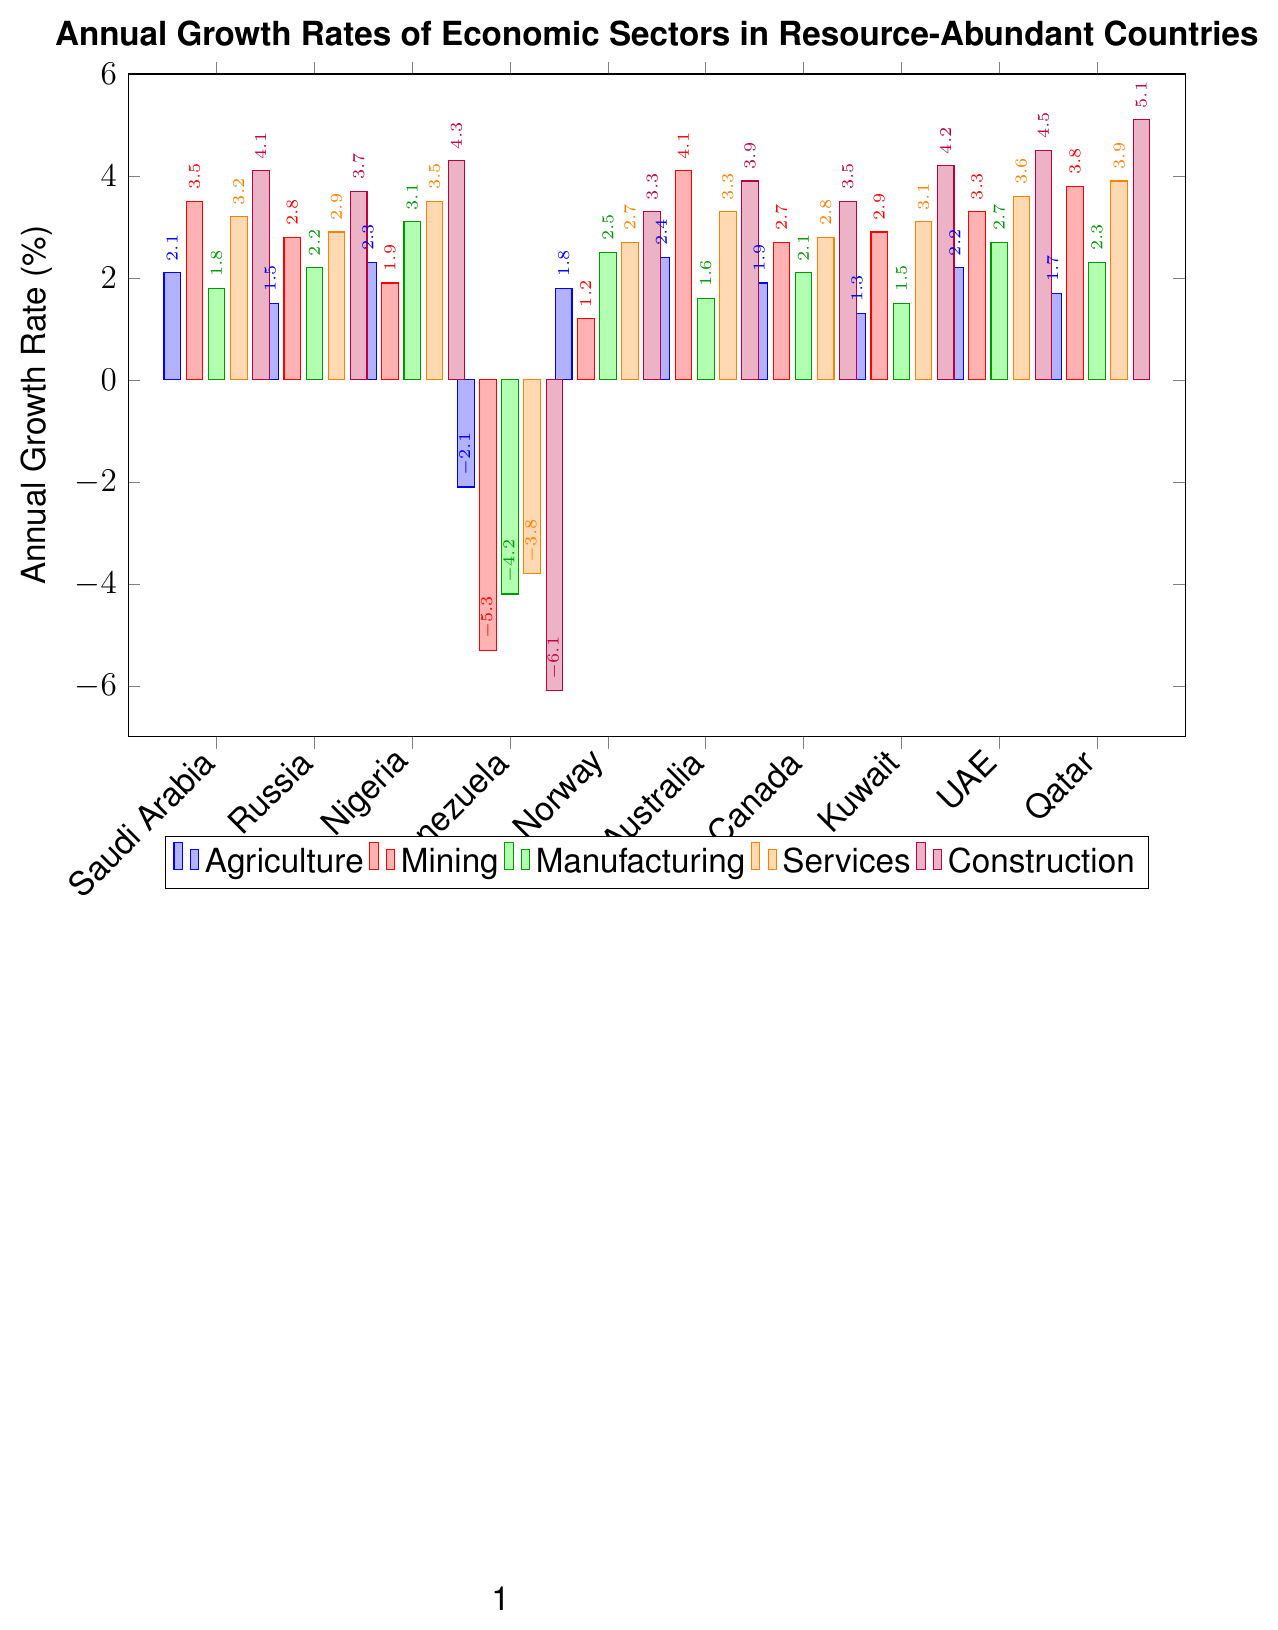What is the annual growth rate of the Agriculture sector in Venezuela? Locate the bar representing the Agriculture growth rate for Venezuela. The bar for Venezuela in the Agriculture sector is labeled with a value of -2.1.
Answer: -2.1% Which country has the highest growth rate in the Mining sector? Compare the heights of the bars representing the Mining sector for all countries. The tallest bar belongs to Australia with a growth rate of 4.1%.
Answer: Australia What is the difference between the growth rates of the Services sector in Saudi Arabia and Qatar? Identify the bars representing the Services sector for Saudi Arabia and Qatar, then subtract the value for Saudi Arabia (3.2) from the value for Qatar (3.9). The difference is 3.9 - 3.2 = 0.7.
Answer: 0.7 Which sector shows the most negative growth rate in Venezuela? Locate all the bars for Venezuela and identify the one with the lowest value. The Construction sector has the most negative growth rate, which is -6.1.
Answer: Construction What is the average growth rate of the Construction sector across all countries? Add the growth rates for the Construction sector for all countries and divide by the number of countries. The values are 4.1, 3.7, 4.3, -6.1, 3.3, 3.9, 3.5, 4.2, 4.5, and 5.1. Sum = 30.5. Average = 30.5 / 10 = 3.05.
Answer: 3.05 Which country has the smallest growth rate in the Manufacturing sector? Compare the heights of the bars representing the Manufacturing sector for all countries. Venezuela has the smallest growth rate with -4.2%.
Answer: Venezuela What is the sum of the growth rates for the Agriculture, Services, and Manufacturing sectors in Russia? Add the respective growth rates for Russia: Agriculture (1.5), Services (2.9), and Manufacturing (2.2). The sum is 1.5 + 2.9 + 2.2 = 6.6.
Answer: 6.6 How does the average growth rate of the Mining sector compare to the average growth rate of the Agriculture sector? Calculate the average growth rate for both sectors. Mining values: 3.5, 2.8, 1.9, -5.3, 1.2, 4.1, 2.7, 2.9, 3.3, 3.8. Sum = 21.9. Average = 21.9 / 10 = 2.19. Agriculture values: 2.1, 1.5, 2.3, -2.1, 1.8, 2.4, 1.9, 1.3, 2.2, 1.7. Sum = 15.1. Average = 15.1 / 10 = 1.51. Compare 2.19 to 1.51.
Answer: The Mining sector's average (2.19) is higher than the Agriculture sector's average (1.51) Which sector in Nigeria has the highest annual growth rate? Compare the heights of the bars representing different sectors for Nigeria. The Construction bar is the tallest with a growth rate of 4.3%.
Answer: Construction Between Canada and Norway, which country has a higher average growth rate across all sectors? Calculate the average growth rate for each country across all sectors. Canada: (1.9 + 2.7 + 2.1 + 2.8 + 3.5) / 5 = 2.6. Norway: (1.8 + 1.2 + 2.5 + 2.7 + 3.3) / 5 = 2.3. Compare the averages.
Answer: Canada 